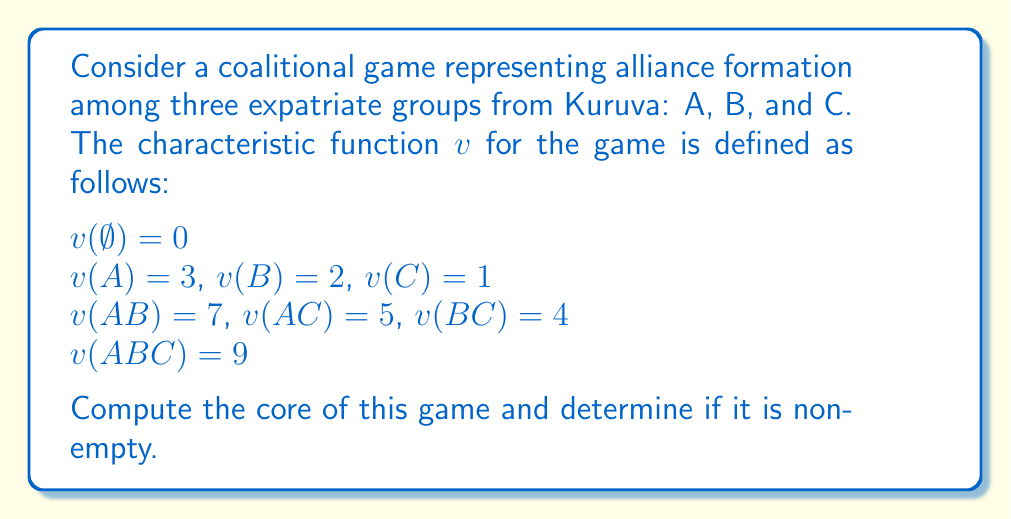Teach me how to tackle this problem. To compute the core of this coalitional game, we need to find all allocations $(x_A, x_B, x_C)$ that satisfy the following conditions:

1. Efficiency: $x_A + x_B + x_C = v(ABC) = 9$
2. Individual rationality: $x_A \geq v(A) = 3$, $x_B \geq v(B) = 2$, $x_C \geq v(C) = 1$
3. Coalitional rationality: $x_A + x_B \geq v(AB) = 7$, $x_A + x_C \geq v(AC) = 5$, $x_B + x_C \geq v(BC) = 4$

Let's solve this step by step:

1. From individual rationality, we know that $x_A \geq 3$, $x_B \geq 2$, and $x_C \geq 1$.

2. From efficiency, we have $x_A + x_B + x_C = 9$.

3. Combining these constraints with coalitional rationality:

   $x_A + x_B \geq 7$
   $x_A + x_C \geq 5$
   $x_B + x_C \geq 4$

4. We can represent the core as a system of linear inequalities:

   $$
   \begin{cases}
   x_A + x_B + x_C = 9 \\
   x_A \geq 3 \\
   x_B \geq 2 \\
   x_C \geq 1 \\
   x_A + x_B \geq 7 \\
   x_A + x_C \geq 5 \\
   x_B + x_C \geq 4
   \end{cases}
   $$

5. Solving this system, we find that the core is non-empty and can be described as:

   $$
   \begin{cases}
   3 \leq x_A \leq 5 \\
   2 \leq x_B \leq 4 \\
   1 \leq x_C \leq 2 \\
   x_A + x_B + x_C = 9
   \end{cases}
   $$

This represents a triangular region in the three-dimensional space of allocations.
Answer: The core of the game is non-empty and is represented by the set of allocations $(x_A, x_B, x_C)$ satisfying:

$$
\begin{cases}
3 \leq x_A \leq 5 \\
2 \leq x_B \leq 4 \\
1 \leq x_C \leq 2 \\
x_A + x_B + x_C = 9
\end{cases}
$$ 